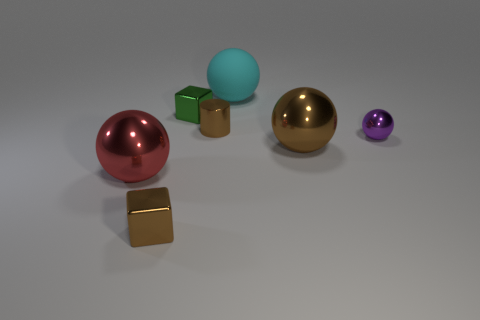Is there any other thing that is made of the same material as the cyan thing?
Offer a very short reply. No. There is a cyan thing that is the same shape as the large red metallic object; what is its material?
Your answer should be compact. Rubber. How many big things are brown balls or green matte blocks?
Your answer should be very brief. 1. What is the cyan ball made of?
Your answer should be very brief. Rubber. What is the big sphere that is both in front of the green metal cube and behind the large red sphere made of?
Offer a terse response. Metal. There is a tiny cylinder; does it have the same color as the large metal sphere that is on the left side of the cyan rubber sphere?
Keep it short and to the point. No. What is the material of the green block that is the same size as the purple thing?
Offer a terse response. Metal. Are there any brown spheres made of the same material as the cyan thing?
Give a very brief answer. No. What number of small brown shiny cubes are there?
Your response must be concise. 1. Does the large brown ball have the same material as the sphere behind the green metallic block?
Ensure brevity in your answer.  No. 